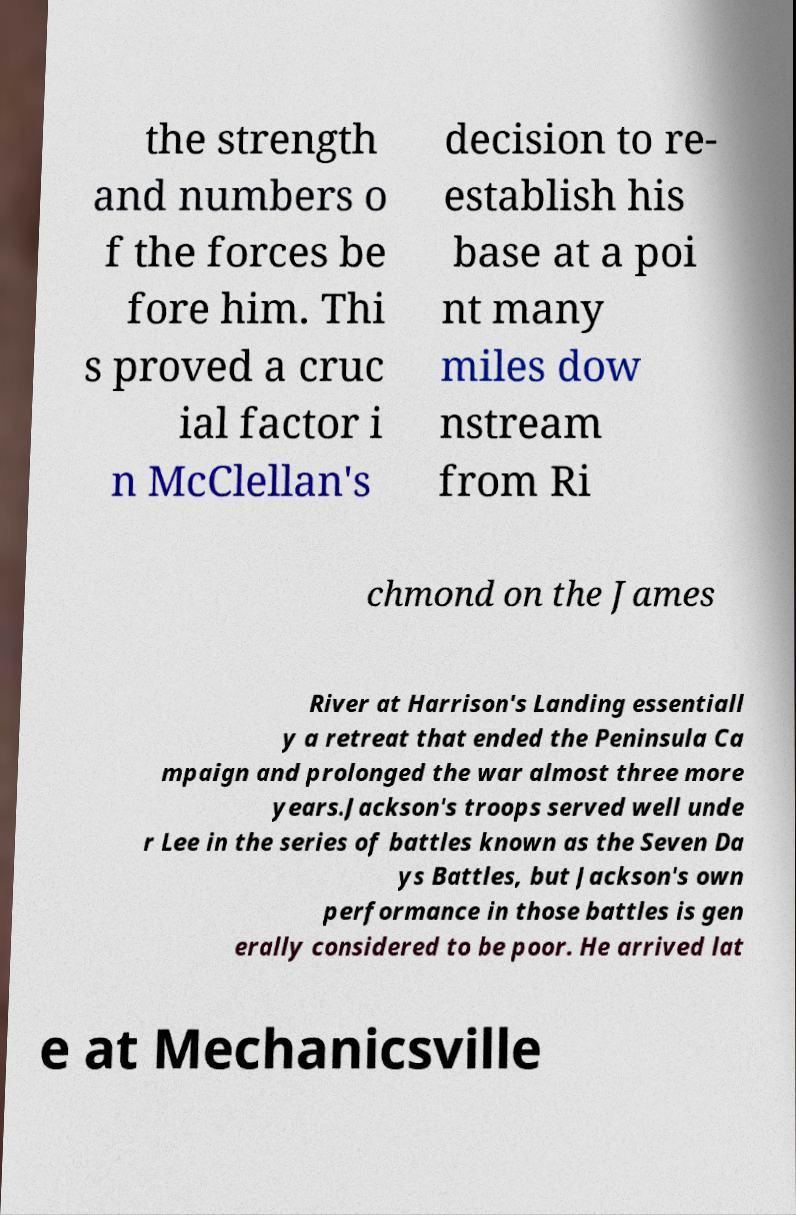Could you extract and type out the text from this image? the strength and numbers o f the forces be fore him. Thi s proved a cruc ial factor i n McClellan's decision to re- establish his base at a poi nt many miles dow nstream from Ri chmond on the James River at Harrison's Landing essentiall y a retreat that ended the Peninsula Ca mpaign and prolonged the war almost three more years.Jackson's troops served well unde r Lee in the series of battles known as the Seven Da ys Battles, but Jackson's own performance in those battles is gen erally considered to be poor. He arrived lat e at Mechanicsville 